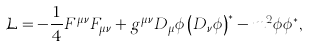Convert formula to latex. <formula><loc_0><loc_0><loc_500><loc_500>\mathcal { L } = \mathcal { - } \frac { 1 } { 4 } F ^ { \mu \nu } F _ { \mu \nu } + g ^ { \mu \nu } D _ { \mu } \phi \left ( D _ { \nu } \phi \right ) ^ { \ast } - m ^ { 2 } \phi \phi ^ { \ast } ,</formula> 